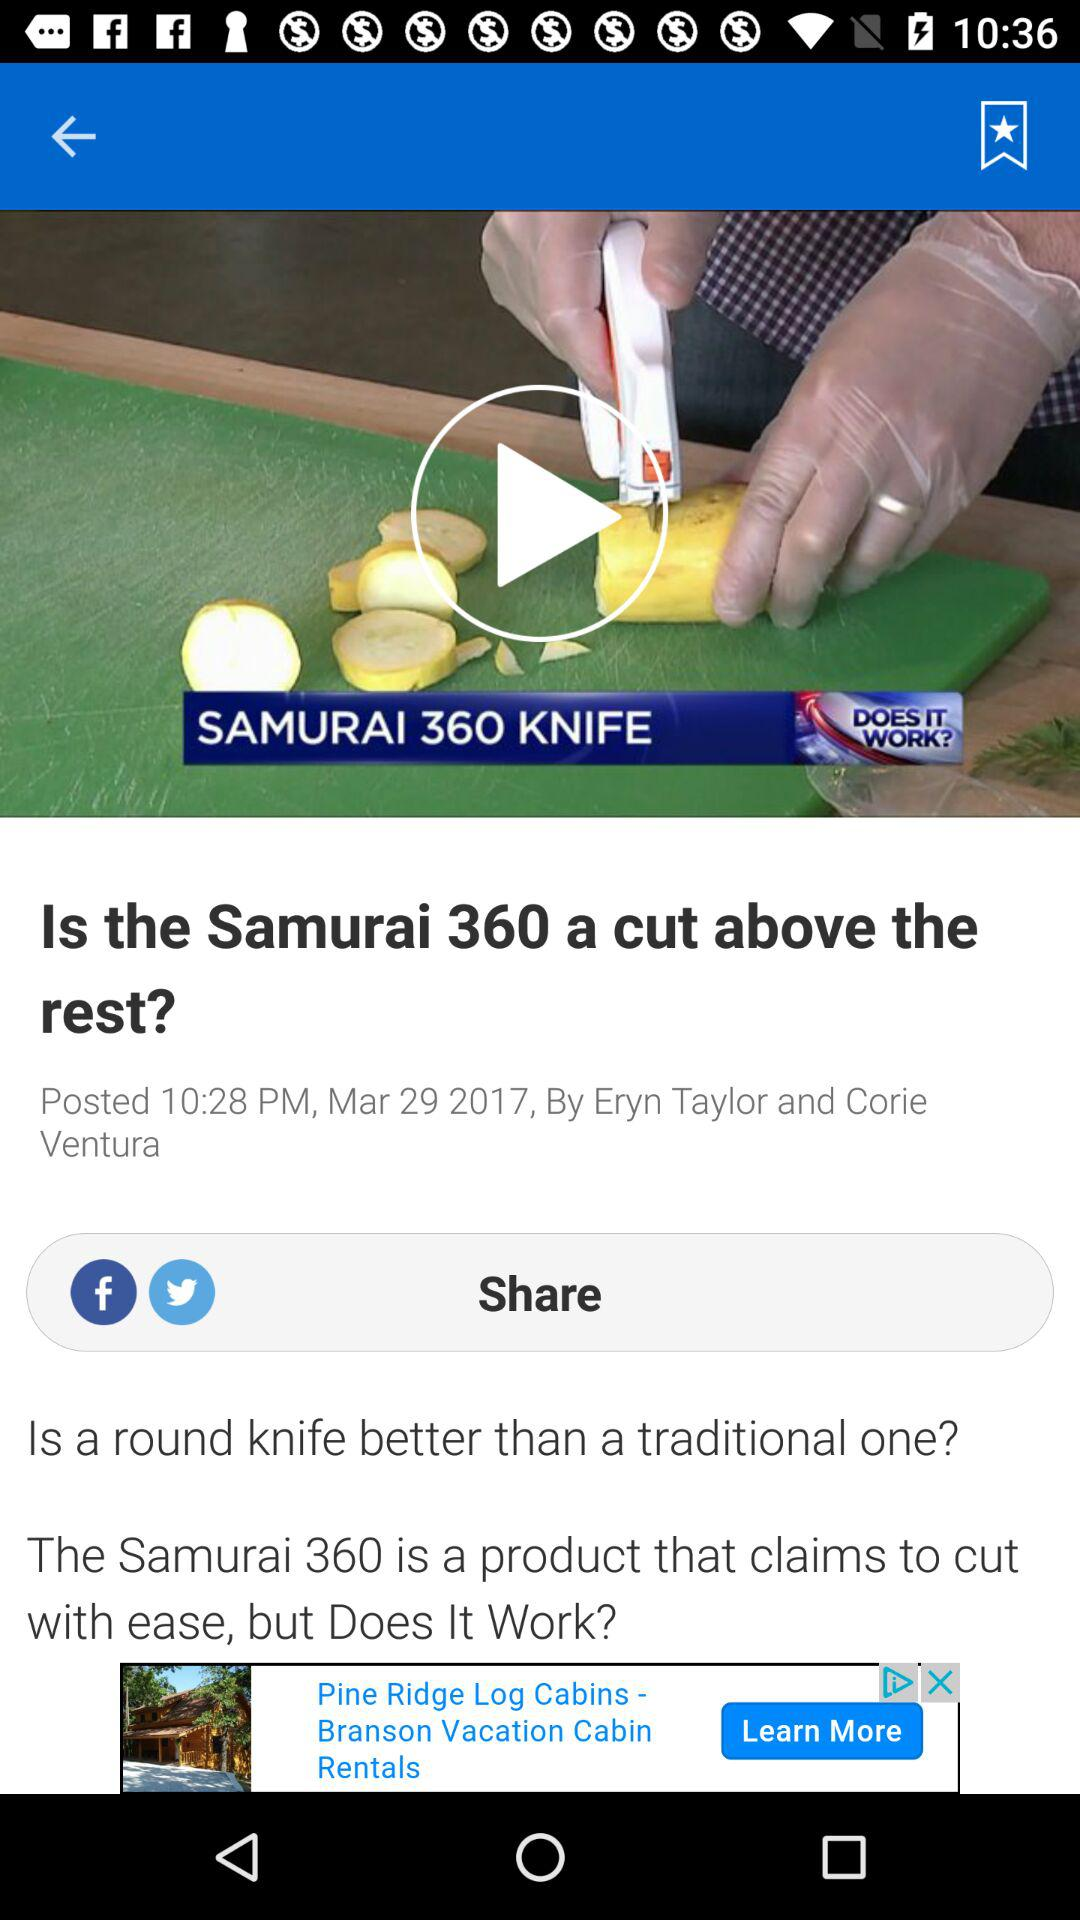Through which application can we share the article? You can share the article through "Facebook" and "Twitter". 